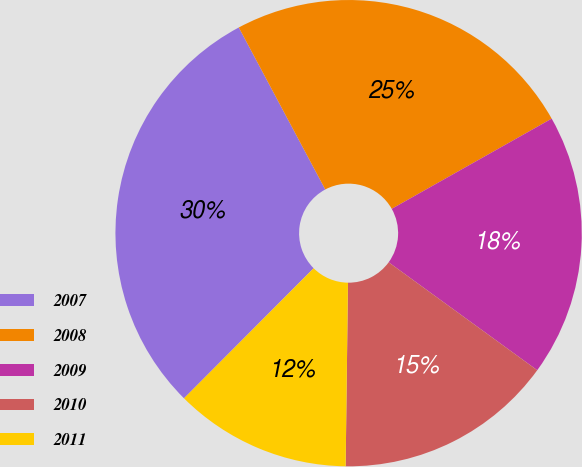Convert chart. <chart><loc_0><loc_0><loc_500><loc_500><pie_chart><fcel>2007<fcel>2008<fcel>2009<fcel>2010<fcel>2011<nl><fcel>29.72%<fcel>24.63%<fcel>18.17%<fcel>15.2%<fcel>12.27%<nl></chart> 